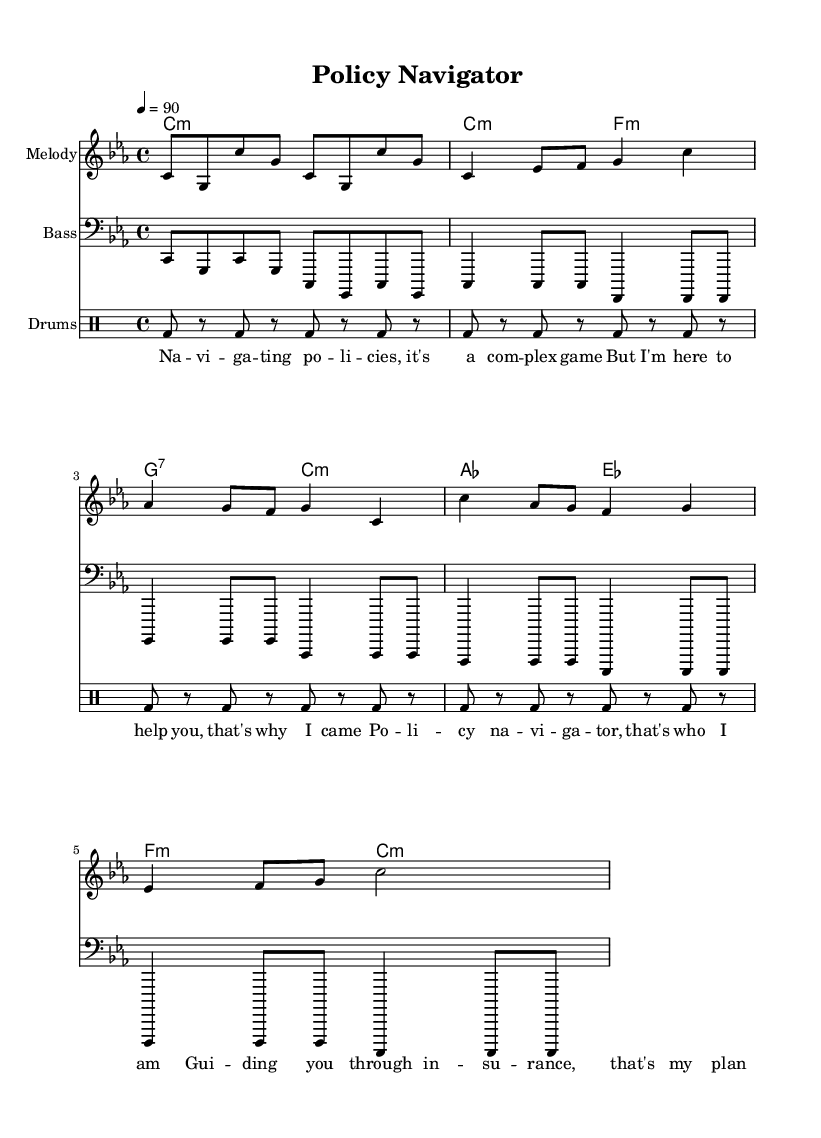What is the key signature of this music? The key signature is C minor, which contains six flats. You can identify this from the key signature markings at the beginning of the staff.
Answer: C minor What is the time signature of the piece? The time signature is 4/4, which indicates four beats per measure. This is typically noted at the beginning of the score and throughout the piece.
Answer: 4/4 What is the tempo marking of the music? The tempo marking is 90 beats per minute, indicated at the beginning of the score. It guides performers on how fast to play the piece.
Answer: 90 How many phrases are in the chorus? The chorus has two phrases, as indicated by the repeated melodic and lyrical structure in the composition. Each phrase is reflected in the notation above the lyrics.
Answer: 2 What is the rhythmic pattern for the drums? The rhythmic pattern for the drums is a bass drum sound followed by rests repeatedly. This is denoted in the drum line section, highlighting the distinct beat.
Answer: Bass drum How does the melody change from the verse to the chorus? The melody transitions from using lower notes in the verse to higher notes in the chorus. This is seen in the pitch of the notes illustrated in the notation.
Answer: Higher notes What role does the bass have in this composition? The bass provides harmonic support and depth while maintaining the rhythm, as outlined in its part on the score where it aligns with the chord changes.
Answer: Harmonic support 